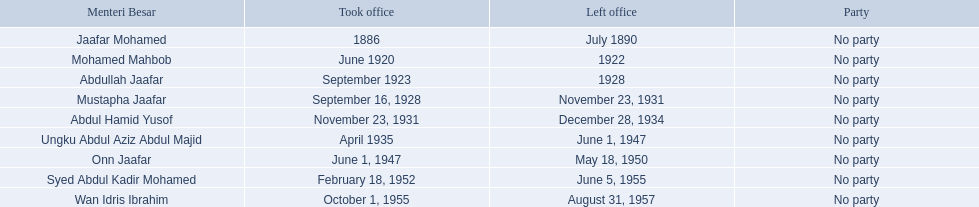Who were the menteri besar of johor? Jaafar Mohamed, Mohamed Mahbob, Abdullah Jaafar, Mustapha Jaafar, Abdul Hamid Yusof, Ungku Abdul Aziz Abdul Majid, Onn Jaafar, Syed Abdul Kadir Mohamed, Wan Idris Ibrahim. Who served the longest? Ungku Abdul Aziz Abdul Majid. 